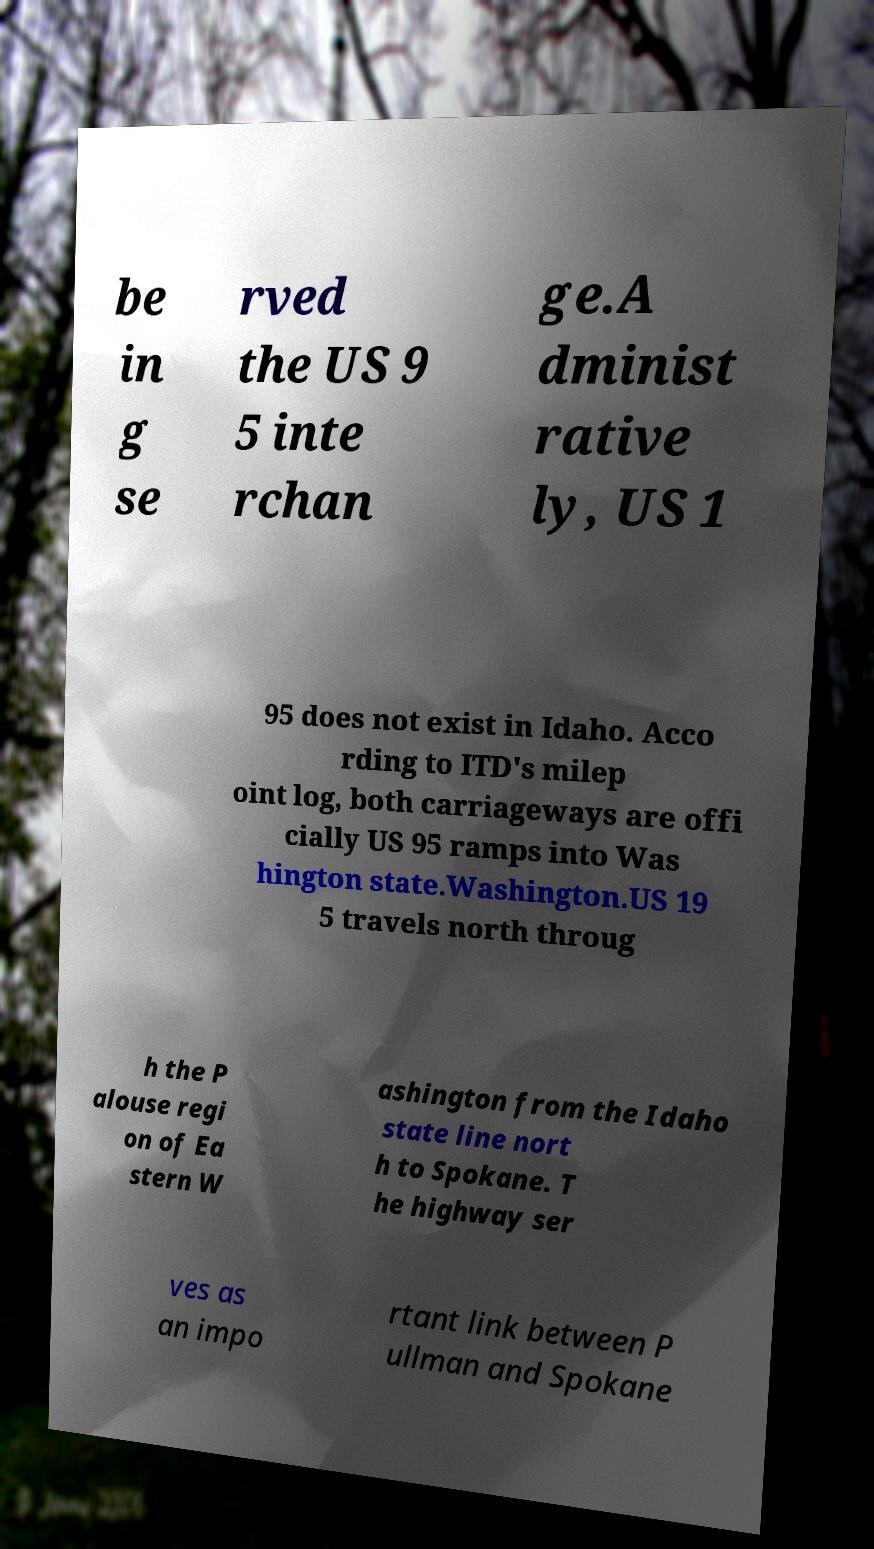Please identify and transcribe the text found in this image. be in g se rved the US 9 5 inte rchan ge.A dminist rative ly, US 1 95 does not exist in Idaho. Acco rding to ITD's milep oint log, both carriageways are offi cially US 95 ramps into Was hington state.Washington.US 19 5 travels north throug h the P alouse regi on of Ea stern W ashington from the Idaho state line nort h to Spokane. T he highway ser ves as an impo rtant link between P ullman and Spokane 